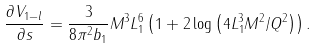<formula> <loc_0><loc_0><loc_500><loc_500>\frac { \partial V _ { 1 - l } } { \partial s } = \frac { 3 } { 8 \pi ^ { 2 } b _ { 1 } } M ^ { 3 } L _ { 1 } ^ { 6 } \left ( 1 + 2 \log \left ( 4 L ^ { 3 } _ { 1 } M ^ { 2 } / Q ^ { 2 } \right ) \right ) .</formula> 